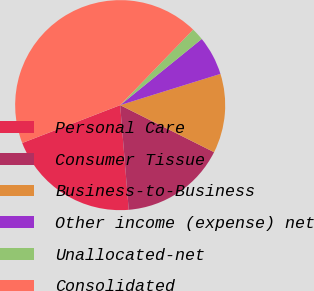<chart> <loc_0><loc_0><loc_500><loc_500><pie_chart><fcel>Personal Care<fcel>Consumer Tissue<fcel>Business-to-Business<fcel>Other income (expense) net<fcel>Unallocated-net<fcel>Consolidated<nl><fcel>20.43%<fcel>16.31%<fcel>12.2%<fcel>6.04%<fcel>1.93%<fcel>43.09%<nl></chart> 